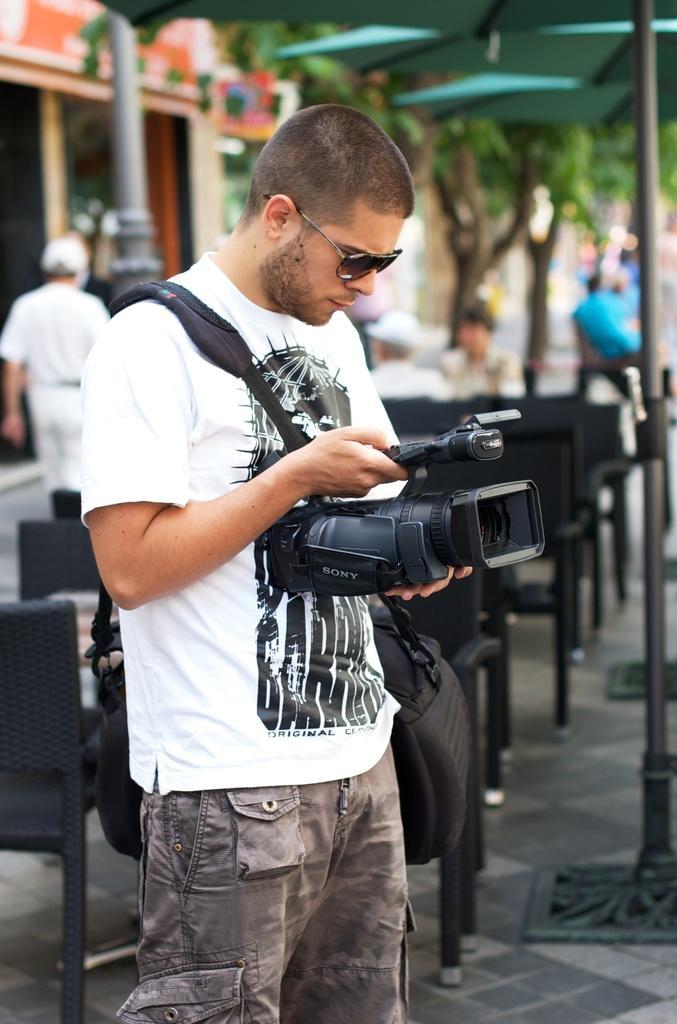Could you give a brief overview of what you see in this image? There is a man standing in the center. He is holding a camera in his hand and he is recording something. In the background we can see a man walking and trees. 